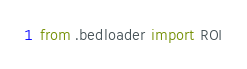Convert code to text. <code><loc_0><loc_0><loc_500><loc_500><_Python_>from .bedloader import ROI
</code> 